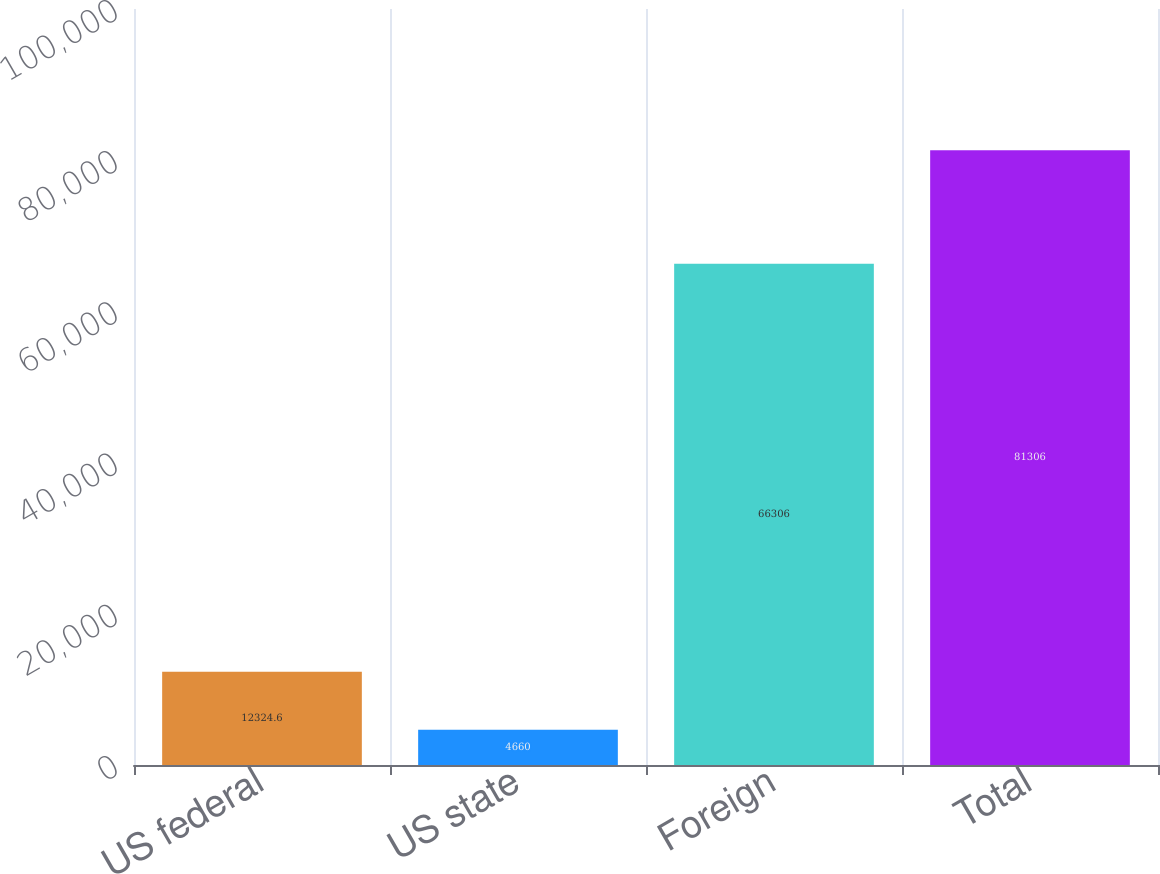<chart> <loc_0><loc_0><loc_500><loc_500><bar_chart><fcel>US federal<fcel>US state<fcel>Foreign<fcel>Total<nl><fcel>12324.6<fcel>4660<fcel>66306<fcel>81306<nl></chart> 